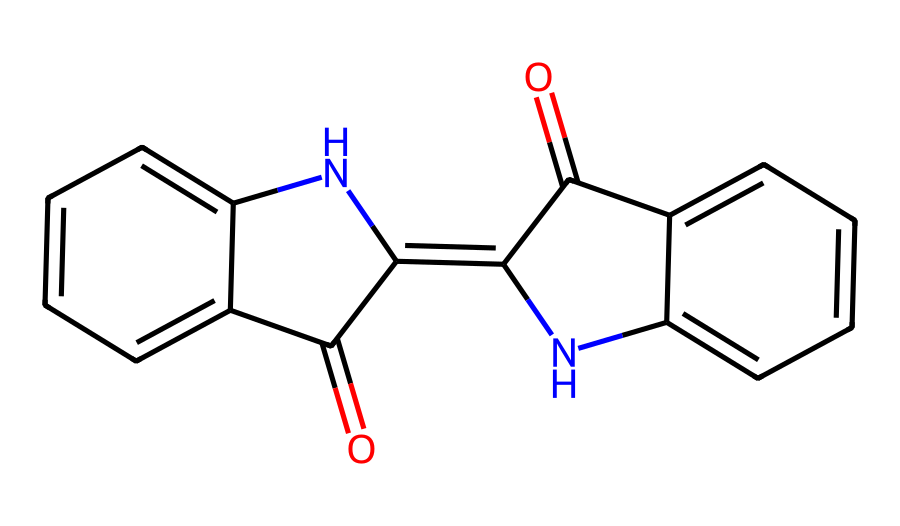What is the molecular formula of indigo? The molecular formula can be derived from counting the number of each type of atom in the SMILES representation. For indigo, there are 16 carbon atoms, 10 hydrogen atoms, 2 nitrogen atoms, and 2 oxygen atoms. Thus, the molecular formula is C16H10N2O2.
Answer: C16H10N2O2 How many rings are present in the structure? The structure of indigo contains three interconnected ring structures, as indicated by the cyclic nature of the SMILES representation. The rings are formed by the arrangement of various atoms, including the nitrogen atoms.
Answer: 3 What type of dye is indigo classified as? Indigo is classified as a natural organic dye, primarily used for dyeing textiles. Its chemical structure, which includes conjugated double bonds, plays a critical role in its ability to absorb visible light, hence producing color.
Answer: natural organic dye How many nitrogen atoms are in the indigo molecule? By examining the SMILES notation, we can see that it explicitly includes two nitrogen atoms, represented by the letters 'N.' Counting their occurrence confirms this number.
Answer: 2 What kind of bond connects the rings in the structure? The rings in indigo are connected through double bonds (C=C), evident from the presence of conjugated systems within the structure that allow for resonance stabilization. This type of bonding is critical for its dyeing properties.
Answer: double bonds Which segment of the molecule is responsible for its color? The presence of the conjugated double bond system allows for effective light absorption, which is responsible for the color of indigo dye. This can be identified in the overarching structure where the alternating single and double bonds form.
Answer: conjugated double bonds 